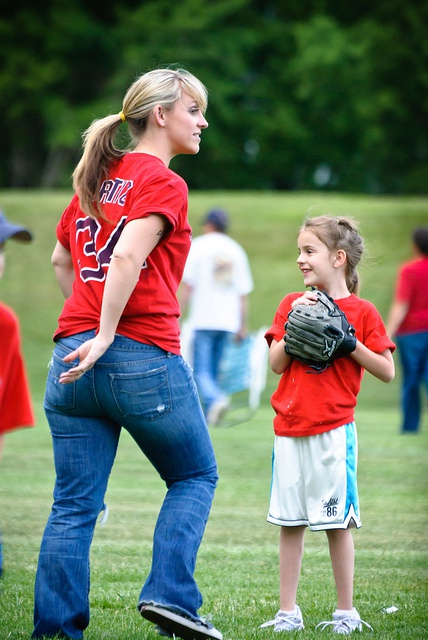Describe the objects in this image and their specific colors. I can see people in black, blue, navy, and red tones, people in black, lightgray, red, darkgray, and lightpink tones, people in black, white, lightblue, and blue tones, people in black, navy, brown, and blue tones, and people in black, red, brown, salmon, and tan tones in this image. 